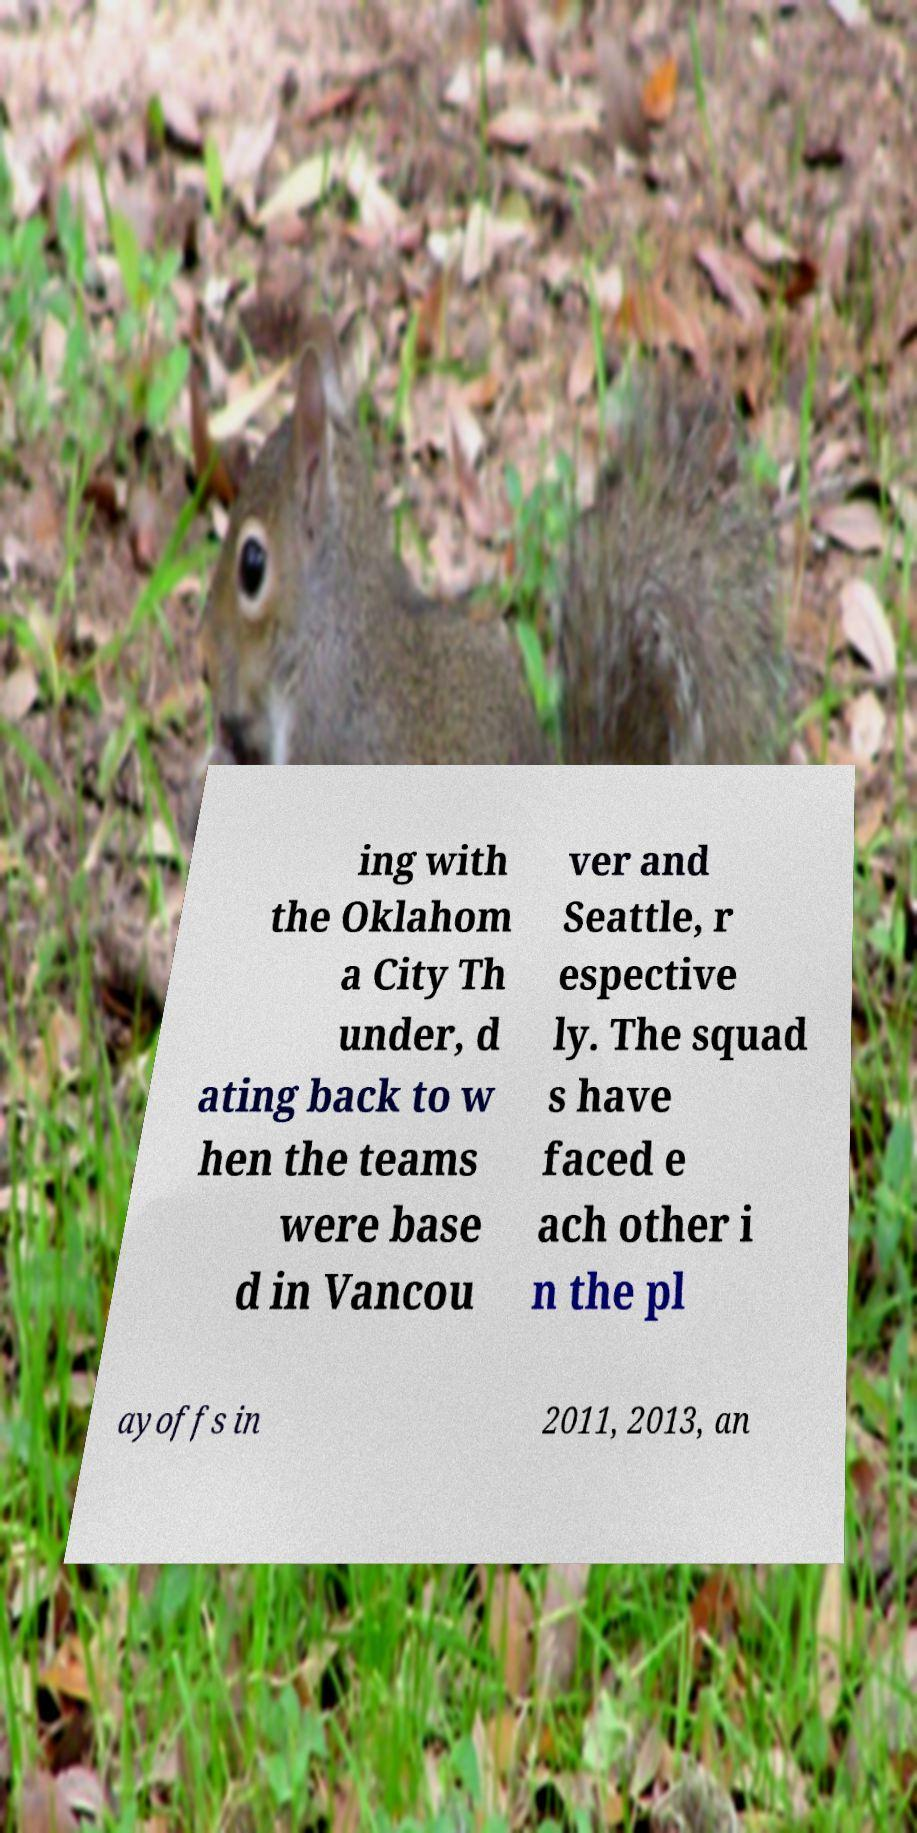Can you read and provide the text displayed in the image?This photo seems to have some interesting text. Can you extract and type it out for me? ing with the Oklahom a City Th under, d ating back to w hen the teams were base d in Vancou ver and Seattle, r espective ly. The squad s have faced e ach other i n the pl ayoffs in 2011, 2013, an 